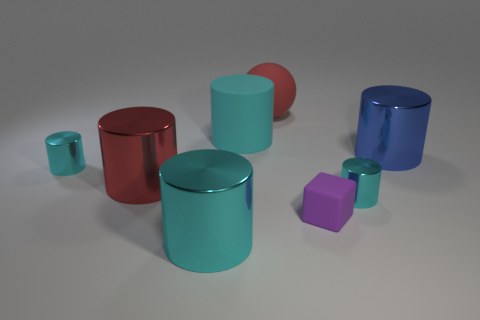There is another big cylinder that is the same color as the rubber cylinder; what is its material?
Ensure brevity in your answer.  Metal. There is a large cyan object that is on the right side of the cyan shiny object in front of the purple block to the left of the big blue metallic thing; what is its shape?
Ensure brevity in your answer.  Cylinder. How many red cylinders have the same material as the ball?
Your answer should be very brief. 0. What number of cylinders are on the right side of the matte object that is to the right of the large red matte sphere?
Your answer should be very brief. 2. How many red cylinders are there?
Your answer should be compact. 1. Are the small purple object and the cyan cylinder that is behind the blue thing made of the same material?
Keep it short and to the point. Yes. Does the small cylinder that is left of the big red sphere have the same color as the rubber cylinder?
Offer a very short reply. Yes. There is a cylinder that is in front of the big red cylinder and on the left side of the red ball; what material is it?
Provide a succinct answer. Metal. What is the size of the purple block?
Your response must be concise. Small. Does the cube have the same color as the small shiny object that is on the left side of the red rubber ball?
Your answer should be compact. No. 